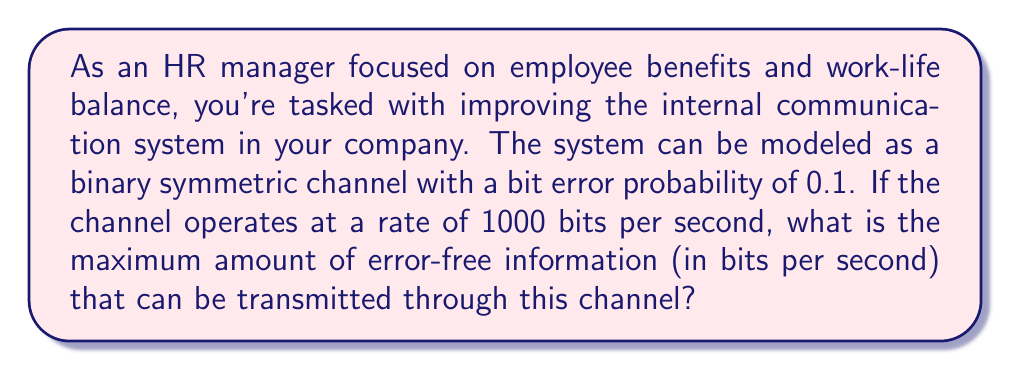Show me your answer to this math problem. To solve this problem, we need to use the concept of channel capacity from information theory. For a binary symmetric channel (BSC), the channel capacity is given by:

$$C = 1 - H(p)$$

Where $C$ is the channel capacity in bits per channel use, and $H(p)$ is the binary entropy function of the error probability $p$.

The binary entropy function is defined as:

$$H(p) = -p \log_2(p) - (1-p) \log_2(1-p)$$

Given:
- Bit error probability, $p = 0.1$
- Channel rate = 1000 bits per second

Steps:
1. Calculate $H(p)$:
   $$H(0.1) = -0.1 \log_2(0.1) - 0.9 \log_2(0.9)$$
   $$\approx 0.469$$

2. Calculate the channel capacity per use:
   $$C = 1 - H(0.1) \approx 1 - 0.469 = 0.531$$

3. Convert to bits per second:
   Maximum error-free information rate = Channel capacity × Channel rate
   $$= 0.531 \times 1000 = 531 \text{ bits per second}$$

This result represents the theoretical maximum rate of error-free information that can be transmitted through this channel, which is relevant for ensuring clear and efficient communication within the company.
Answer: 531 bits per second 